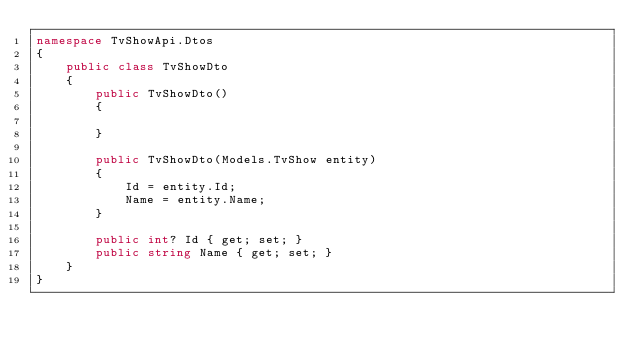Convert code to text. <code><loc_0><loc_0><loc_500><loc_500><_C#_>namespace TvShowApi.Dtos
{
    public class TvShowDto
    {
        public TvShowDto()
        {

        }

        public TvShowDto(Models.TvShow entity)
        {
            Id = entity.Id;
            Name = entity.Name;
        }

        public int? Id { get; set; }
        public string Name { get; set; }
    }
}
</code> 